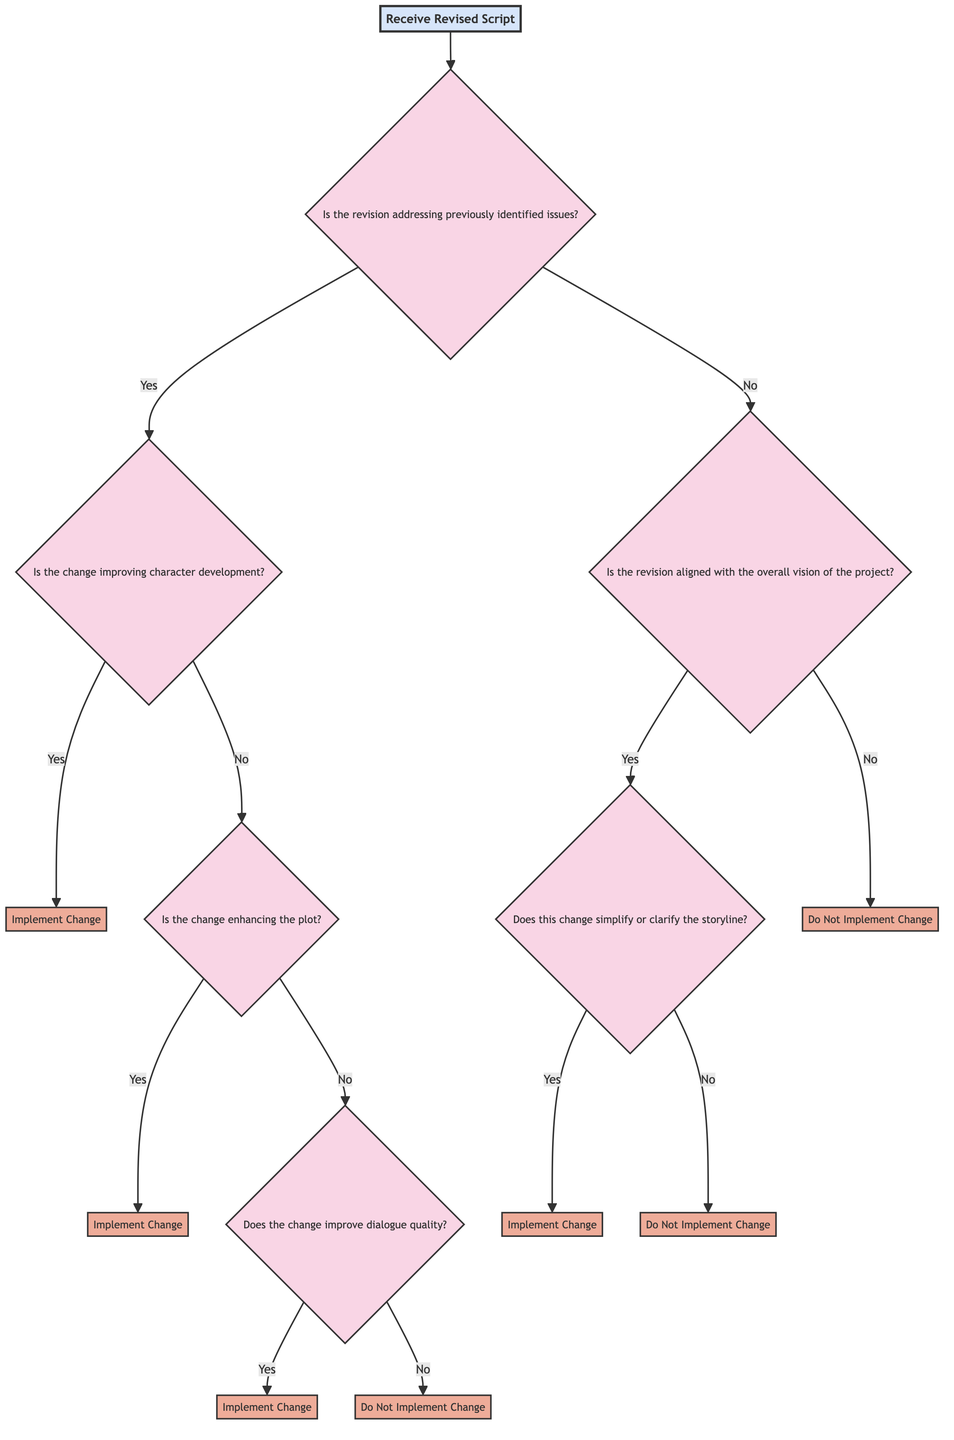What is the root node of the decision tree? The root node is the starting point of the decision tree, which is labeled "Receive Revised Script".
Answer: Receive Revised Script How many action nodes are present in the diagram? There are six action nodes in the diagram: "Implement Change" and "Do Not Implement Change". Counting each instance of "Implement Change" and "Do Not Implement Change" gives a total of six.
Answer: Six What happens if the revision does not address previously identified issues? If the revision does not address previously identified issues, the next question to evaluate is "Is the revision aligned with the overall vision of the project?". This will lead to either implementing or not implementing the change based on the answer given to that question.
Answer: Evaluate alignment with vision Is "Implement Change" a possible outcome of the decision tree? Yes, "Implement Change" is a possible outcome at several decision points in the tree, specifically under conditions that improve character development, enhance the plot, or improve dialogue quality.
Answer: Yes What is the last question in the diagram? The last question in the diagram is "Does this change simplify or clarify the storyline?". This question determines whether to implement the change when alignment with the overall vision is confirmed.
Answer: Does this change simplify or clarify the storyline? What leads to the conclusion of "Do Not Implement Change"? "Do Not Implement Change" is reached in multiple pathways: (1) when revisions do not address previously identified issues and do not align with the overall vision, (2) when identified issues are not addressed and the change does not improve character development, enhance plot, or improve dialogue quality.
Answer: Multiple pathways 